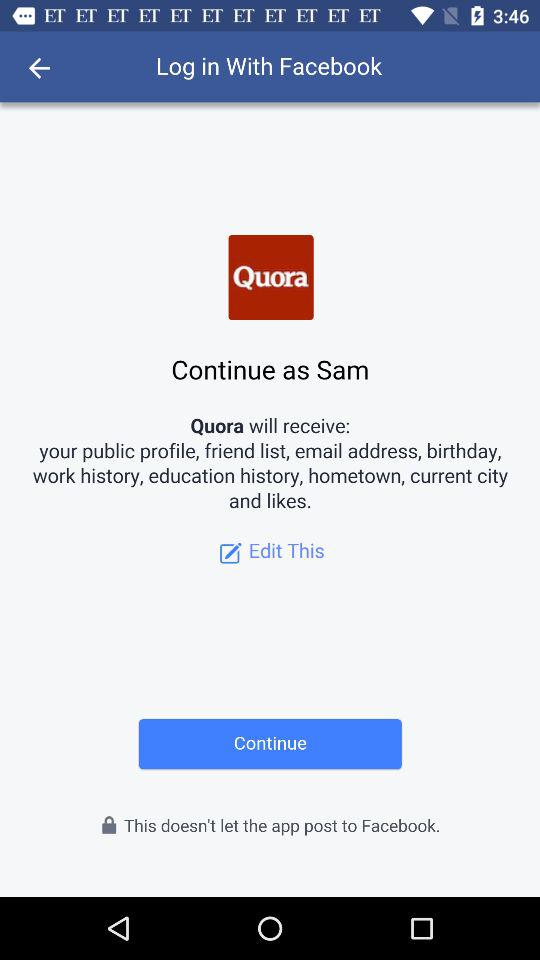What is the name of the user? The name of the user is Sam. 